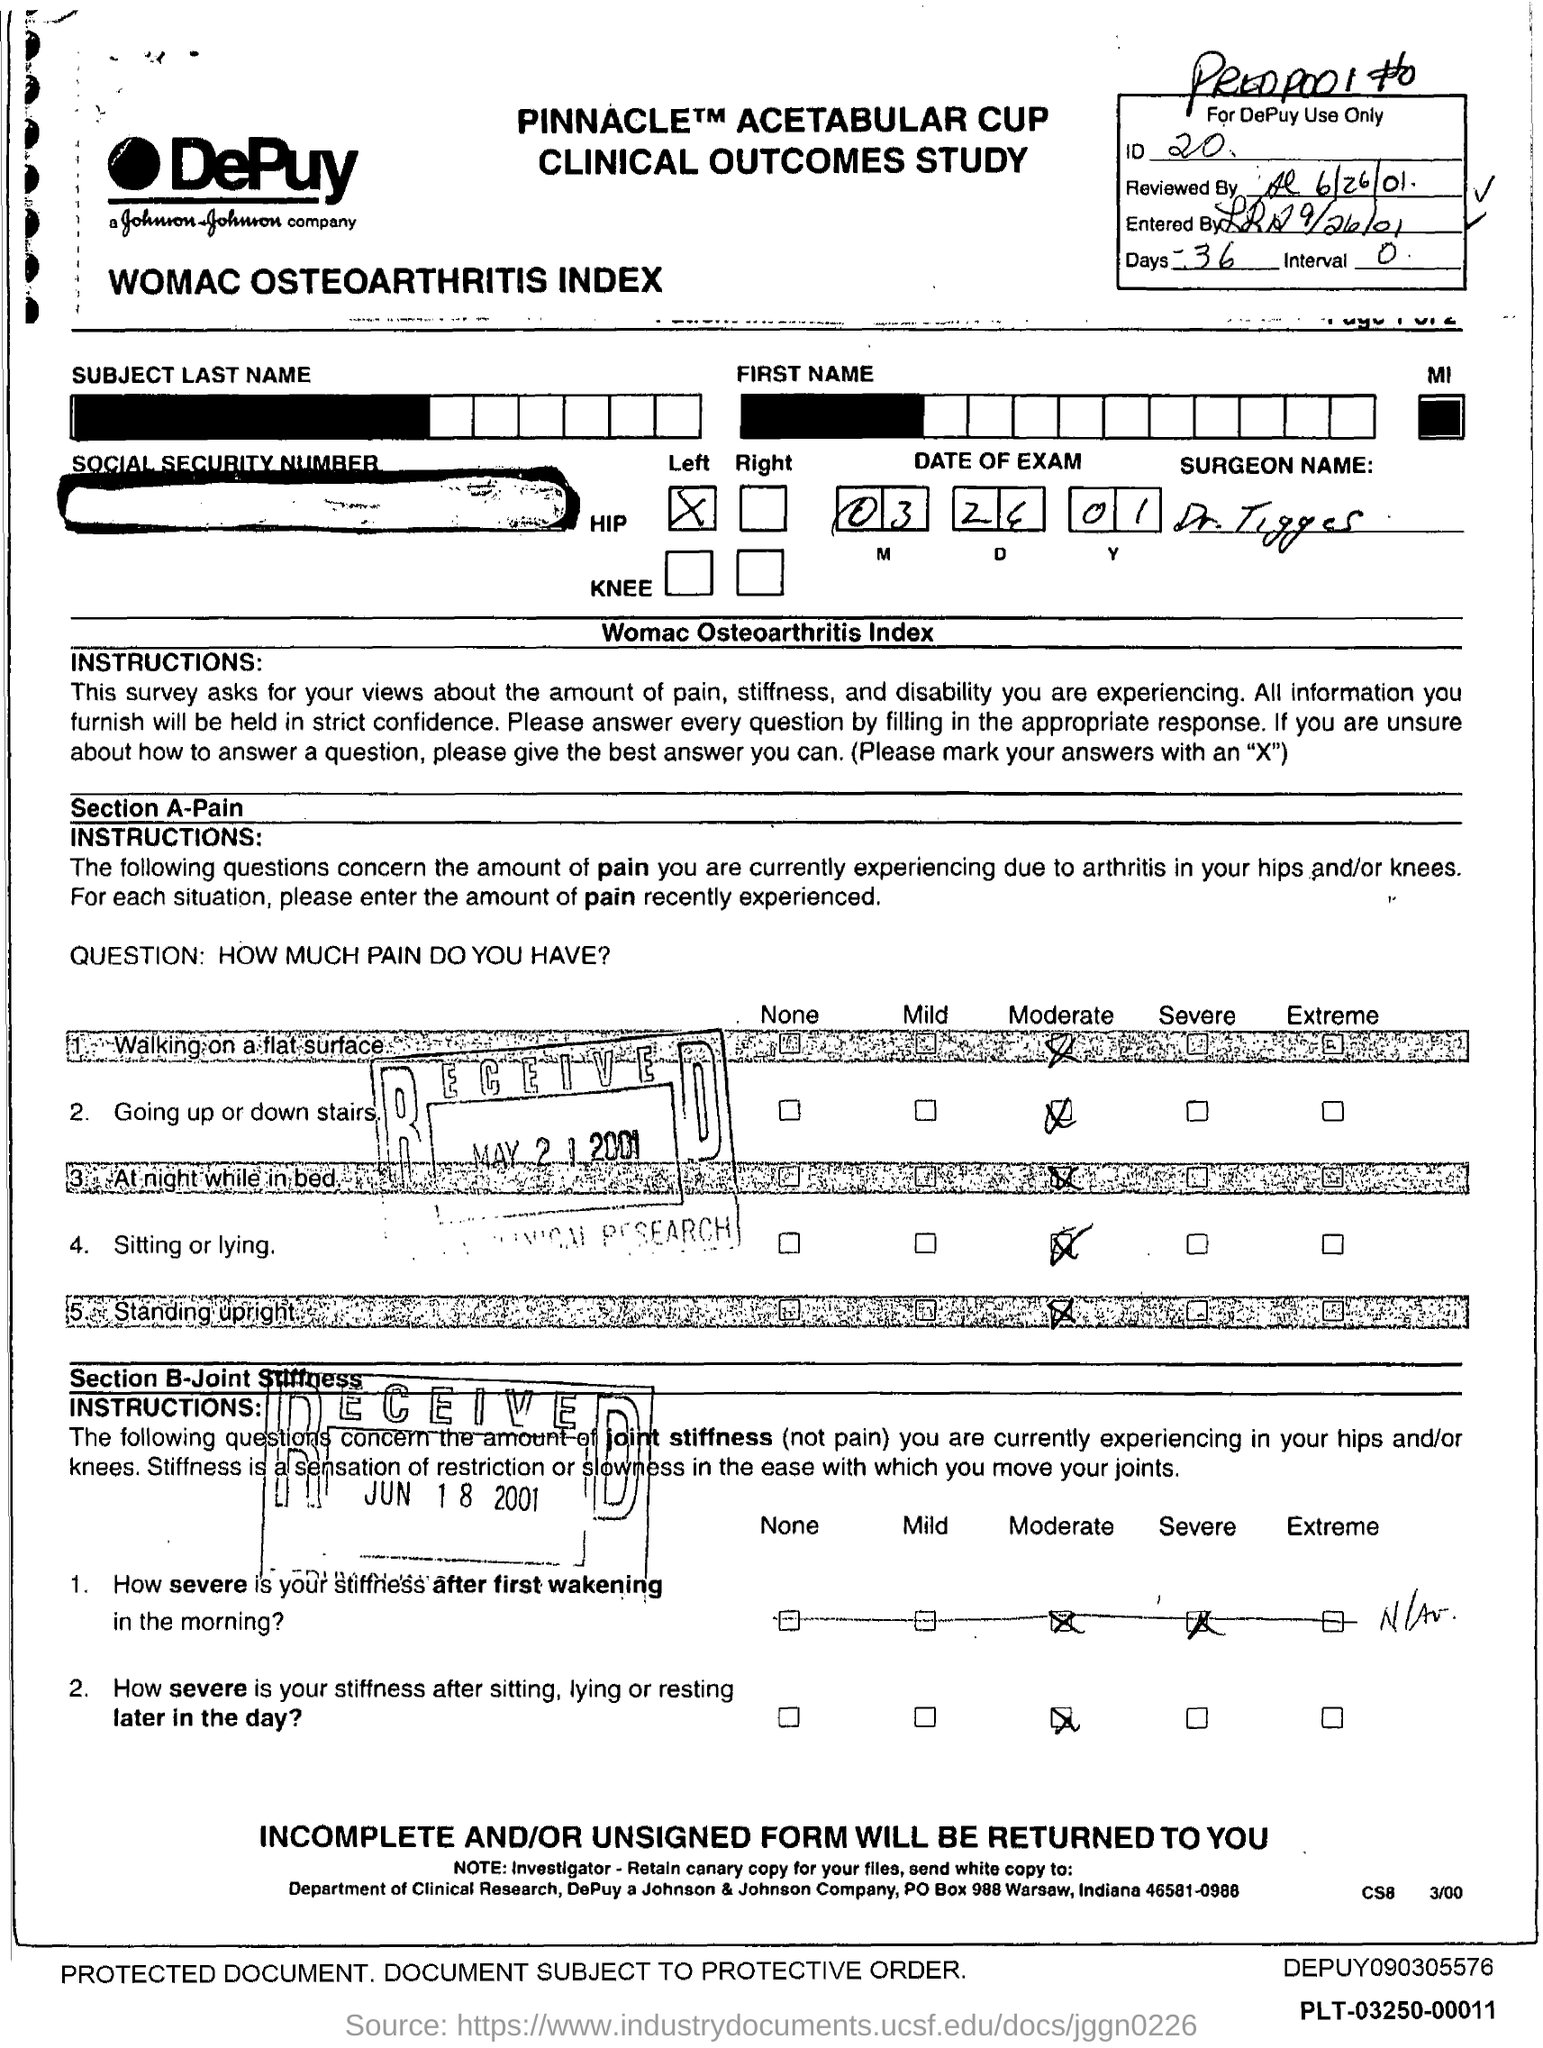Outline some significant characteristics in this image. The interval mentioned in the form is 0.. The ID mentioned in the form is 20. 